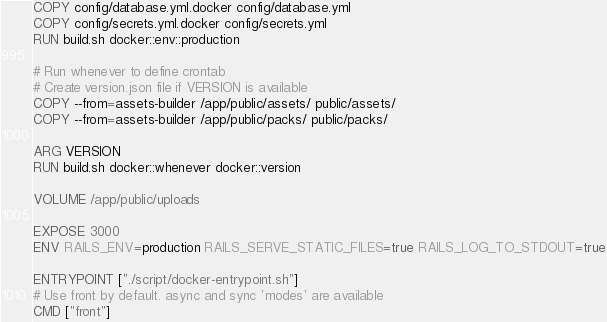Convert code to text. <code><loc_0><loc_0><loc_500><loc_500><_Dockerfile_>COPY config/database.yml.docker config/database.yml
COPY config/secrets.yml.docker config/secrets.yml
RUN build.sh docker::env::production

# Run whenever to define crontab
# Create version.json file if VERSION is available
COPY --from=assets-builder /app/public/assets/ public/assets/
COPY --from=assets-builder /app/public/packs/ public/packs/

ARG VERSION
RUN build.sh docker::whenever docker::version

VOLUME /app/public/uploads

EXPOSE 3000
ENV RAILS_ENV=production RAILS_SERVE_STATIC_FILES=true RAILS_LOG_TO_STDOUT=true

ENTRYPOINT ["./script/docker-entrypoint.sh"]
# Use front by default. async and sync 'modes' are available
CMD ["front"]
</code> 